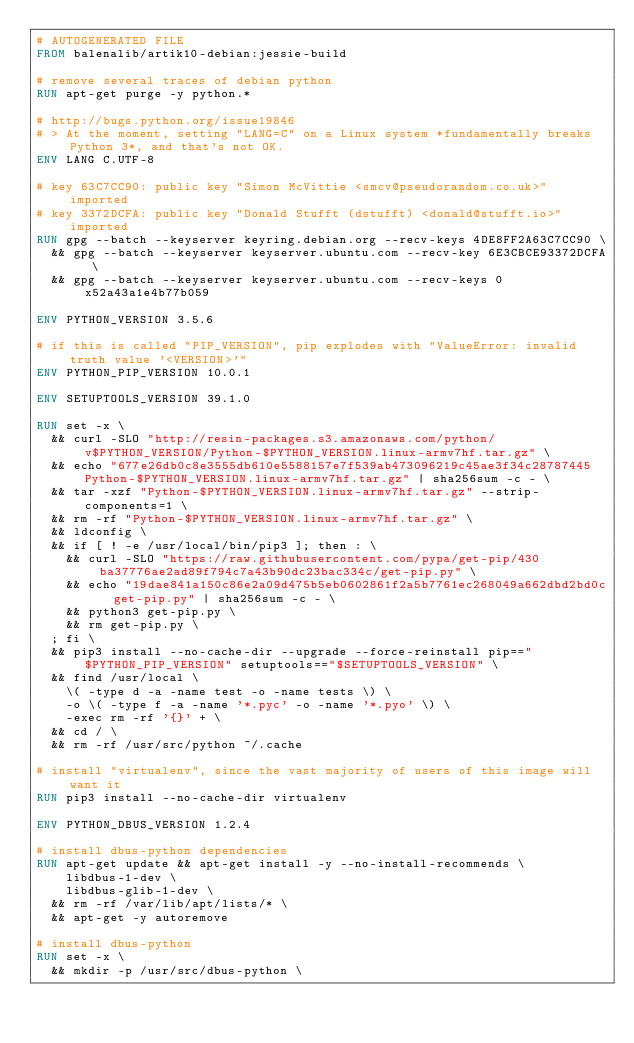<code> <loc_0><loc_0><loc_500><loc_500><_Dockerfile_># AUTOGENERATED FILE
FROM balenalib/artik10-debian:jessie-build

# remove several traces of debian python
RUN apt-get purge -y python.*

# http://bugs.python.org/issue19846
# > At the moment, setting "LANG=C" on a Linux system *fundamentally breaks Python 3*, and that's not OK.
ENV LANG C.UTF-8

# key 63C7CC90: public key "Simon McVittie <smcv@pseudorandom.co.uk>" imported
# key 3372DCFA: public key "Donald Stufft (dstufft) <donald@stufft.io>" imported
RUN gpg --batch --keyserver keyring.debian.org --recv-keys 4DE8FF2A63C7CC90 \
	&& gpg --batch --keyserver keyserver.ubuntu.com --recv-key 6E3CBCE93372DCFA \
	&& gpg --batch --keyserver keyserver.ubuntu.com --recv-keys 0x52a43a1e4b77b059

ENV PYTHON_VERSION 3.5.6

# if this is called "PIP_VERSION", pip explodes with "ValueError: invalid truth value '<VERSION>'"
ENV PYTHON_PIP_VERSION 10.0.1

ENV SETUPTOOLS_VERSION 39.1.0

RUN set -x \
	&& curl -SLO "http://resin-packages.s3.amazonaws.com/python/v$PYTHON_VERSION/Python-$PYTHON_VERSION.linux-armv7hf.tar.gz" \
	&& echo "677e26db0c8e3555db610e5588157e7f539ab473096219c45ae3f34c28787445  Python-$PYTHON_VERSION.linux-armv7hf.tar.gz" | sha256sum -c - \
	&& tar -xzf "Python-$PYTHON_VERSION.linux-armv7hf.tar.gz" --strip-components=1 \
	&& rm -rf "Python-$PYTHON_VERSION.linux-armv7hf.tar.gz" \
	&& ldconfig \
	&& if [ ! -e /usr/local/bin/pip3 ]; then : \
		&& curl -SLO "https://raw.githubusercontent.com/pypa/get-pip/430ba37776ae2ad89f794c7a43b90dc23bac334c/get-pip.py" \
		&& echo "19dae841a150c86e2a09d475b5eb0602861f2a5b7761ec268049a662dbd2bd0c  get-pip.py" | sha256sum -c - \
		&& python3 get-pip.py \
		&& rm get-pip.py \
	; fi \
	&& pip3 install --no-cache-dir --upgrade --force-reinstall pip=="$PYTHON_PIP_VERSION" setuptools=="$SETUPTOOLS_VERSION" \
	&& find /usr/local \
		\( -type d -a -name test -o -name tests \) \
		-o \( -type f -a -name '*.pyc' -o -name '*.pyo' \) \
		-exec rm -rf '{}' + \
	&& cd / \
	&& rm -rf /usr/src/python ~/.cache

# install "virtualenv", since the vast majority of users of this image will want it
RUN pip3 install --no-cache-dir virtualenv

ENV PYTHON_DBUS_VERSION 1.2.4

# install dbus-python dependencies 
RUN apt-get update && apt-get install -y --no-install-recommends \
		libdbus-1-dev \
		libdbus-glib-1-dev \
	&& rm -rf /var/lib/apt/lists/* \
	&& apt-get -y autoremove

# install dbus-python
RUN set -x \
	&& mkdir -p /usr/src/dbus-python \</code> 